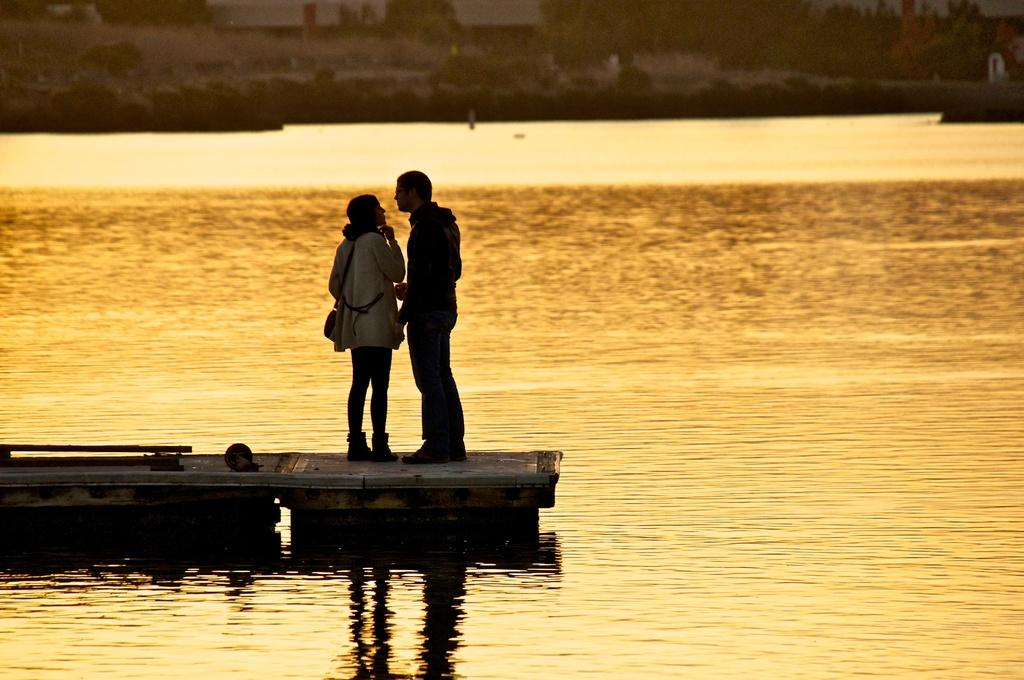How many people are in the image? There are two persons in the image. What are the two persons doing in the image? The two persons are standing on a boat. What can be seen in the background of the image? There is water visible in the image. What type of snails can be seen crawling on the boat in the image? There are no snails present in the image; it features two persons standing on a boat. Can you tell me how many dolls are visible on the boat in the image? There are no dolls present in the image; it features two persons standing on a boat. 